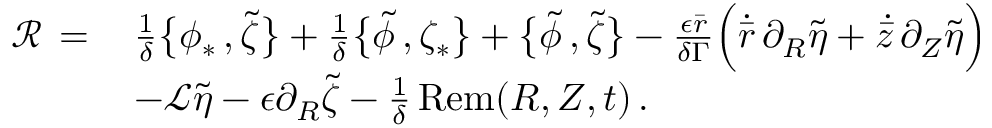<formula> <loc_0><loc_0><loc_500><loc_500>\begin{array} { r l } { \mathcal { R } \, = \, } & { \frac { 1 } { \delta } \left \{ \phi _ { * } \, , \tilde { \zeta } \right \} + \frac { 1 } { \delta } \left \{ \tilde { \phi } \, , \zeta _ { * } \right \} + \left \{ \tilde { \phi } \, , \tilde { \zeta } \right \} - \frac { \epsilon \bar { r } } { \delta \Gamma } \left ( \dot { \bar { r } } \, \partial _ { R } \tilde { \eta } + \dot { \bar { z } } \, \partial _ { Z } \tilde { \eta } \right ) } \\ & { - \mathcal { L } \tilde { \eta } - \epsilon \partial _ { R } \tilde { \zeta } - \frac { 1 } { \delta } \, R e m ( R , Z , t ) \, . } \end{array}</formula> 